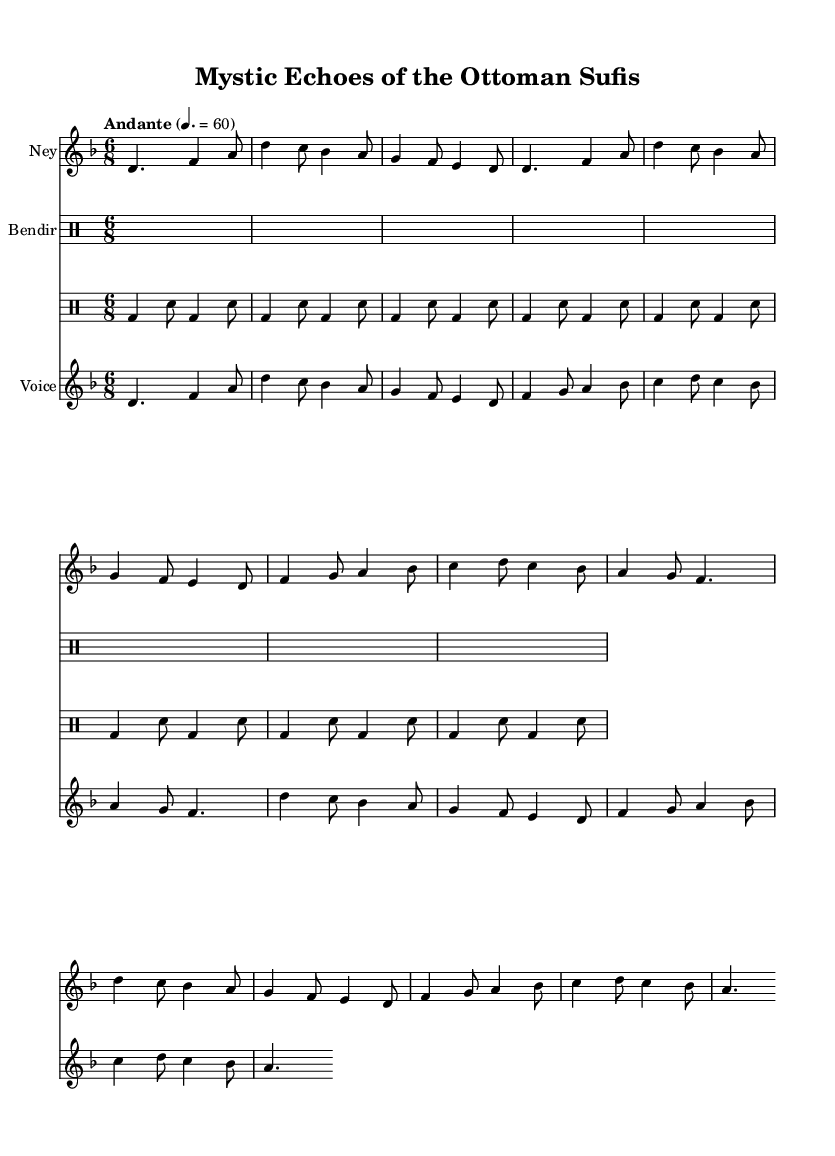What is the key signature of this music? The key signature is D minor, indicated by one flat (B flat). The 'd' in the global block refers to the relative pitch, and the note names and accidentals confirm this.
Answer: D minor What is the time signature of this music? The time signature is 6/8, as shown in the global section. This indicates a compound meter with six eighth notes per measure.
Answer: 6/8 What is the tempo marking of the piece? The tempo marking indicates "Andante" with a quarter note equal to 60 beats per minute (BPM), which suggests a moderately slow tempo.
Answer: Andante How many measures are in the verse section of the music? By counting the measures indicated in the 'neyMusic' and 'voicePart' sections, we find that there are a total of 8 measures in the verse section.
Answer: 8 What instruments are used in this score? The score includes three instruments: Ney, Bendir, and Voice. Each is assigned to its respective staff, allowing for a diverse instrumental arrangement.
Answer: Ney, Bendir, Voice What is the main theme referred to in the chorus lyrics? The main theme in the chorus lyrics revolves around the divine presence of Allah, emphasizing spirituality in each breath. This reflects the Sufi focus on the intimate relationship with the divine.
Answer: Divine presence How does the structure of this piece reflect Sufi principles? The structure of the piece, with its repeated musical phrases (in both the verse and chorus), symbolizes the Sufi practice of remembrance (dhikr) and meditation on the divine, reinforcing the spirituality and mysticism central to Sufi philosophy.
Answer: Repeated phrases for reflection 